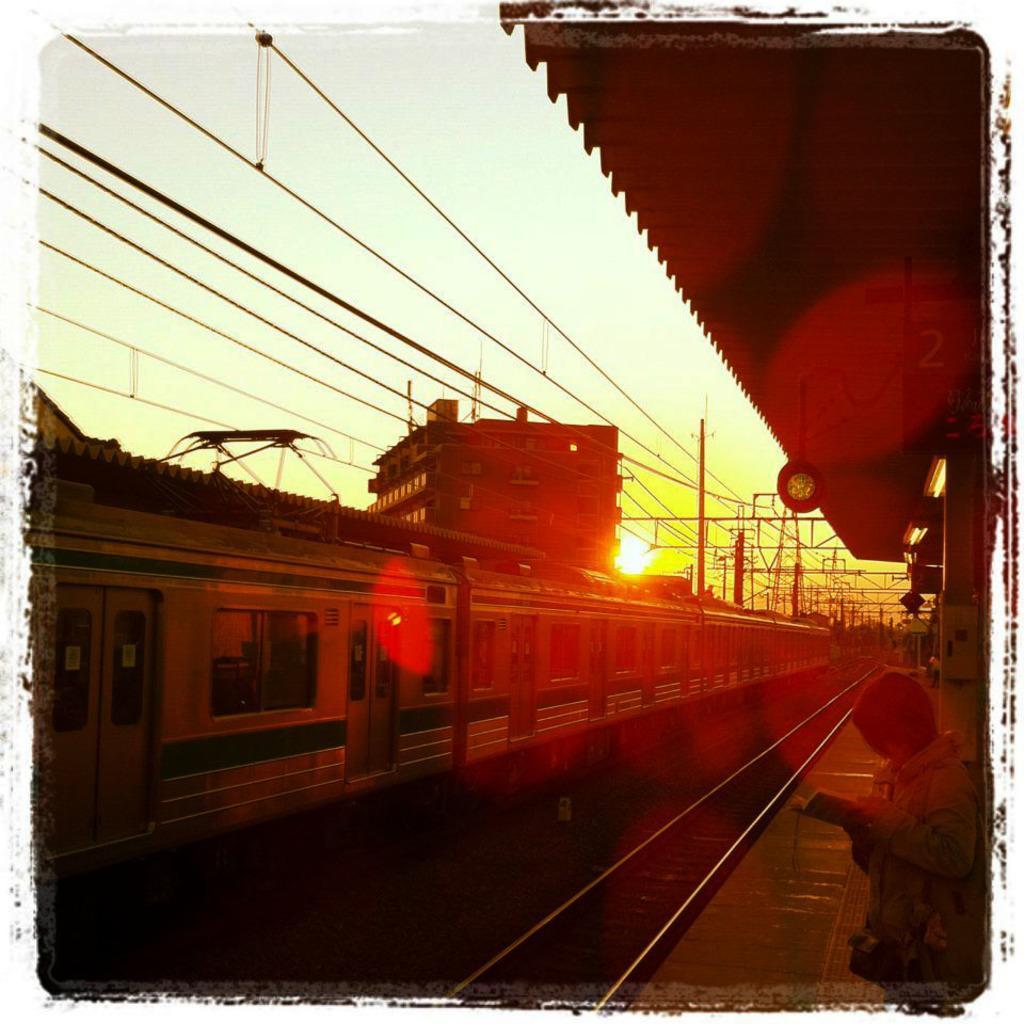Describe this image in one or two sentences. In this picture we can see a train, railway track, person holding a book and standing on a platform, roof, building, wires, poles and some objects and in the background we can see the sky. 